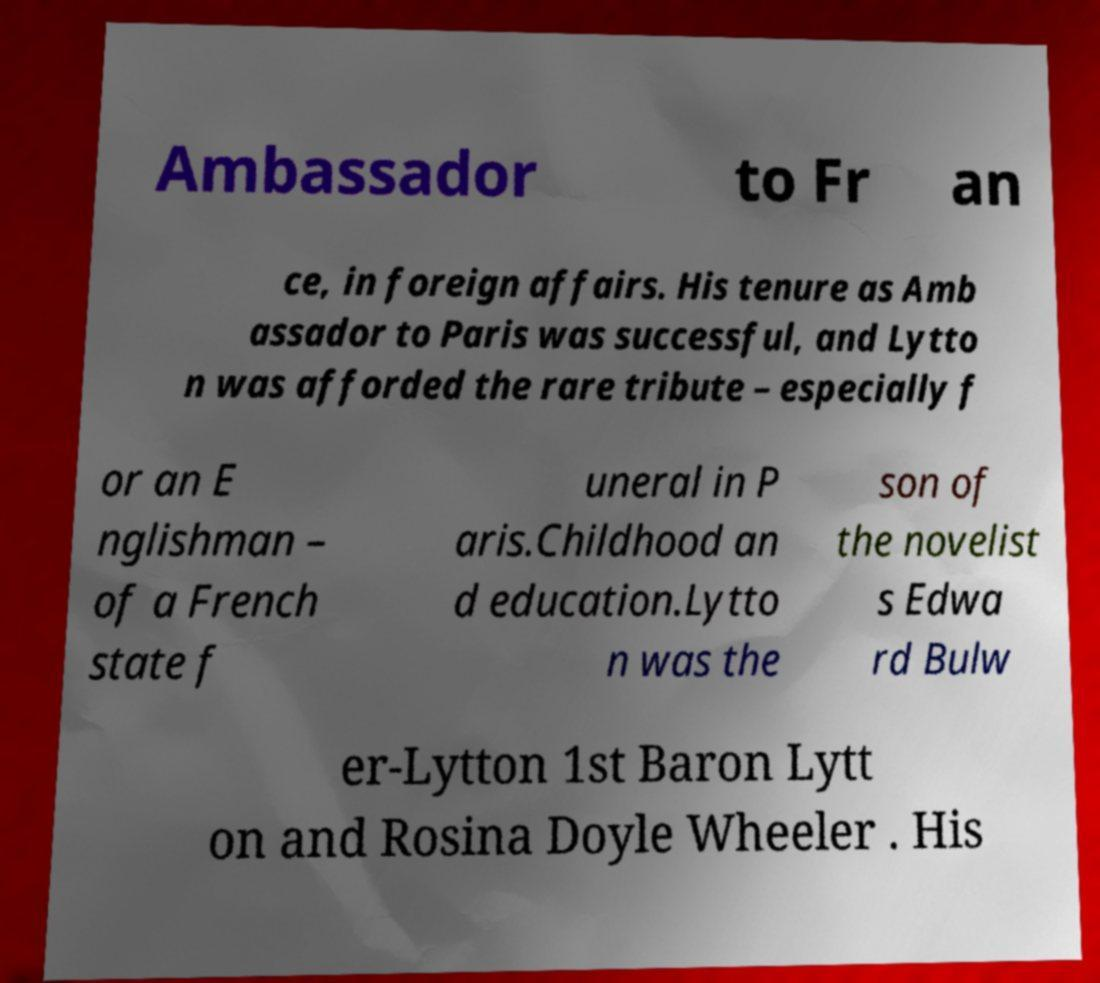Please read and relay the text visible in this image. What does it say? Ambassador to Fr an ce, in foreign affairs. His tenure as Amb assador to Paris was successful, and Lytto n was afforded the rare tribute – especially f or an E nglishman – of a French state f uneral in P aris.Childhood an d education.Lytto n was the son of the novelist s Edwa rd Bulw er-Lytton 1st Baron Lytt on and Rosina Doyle Wheeler . His 